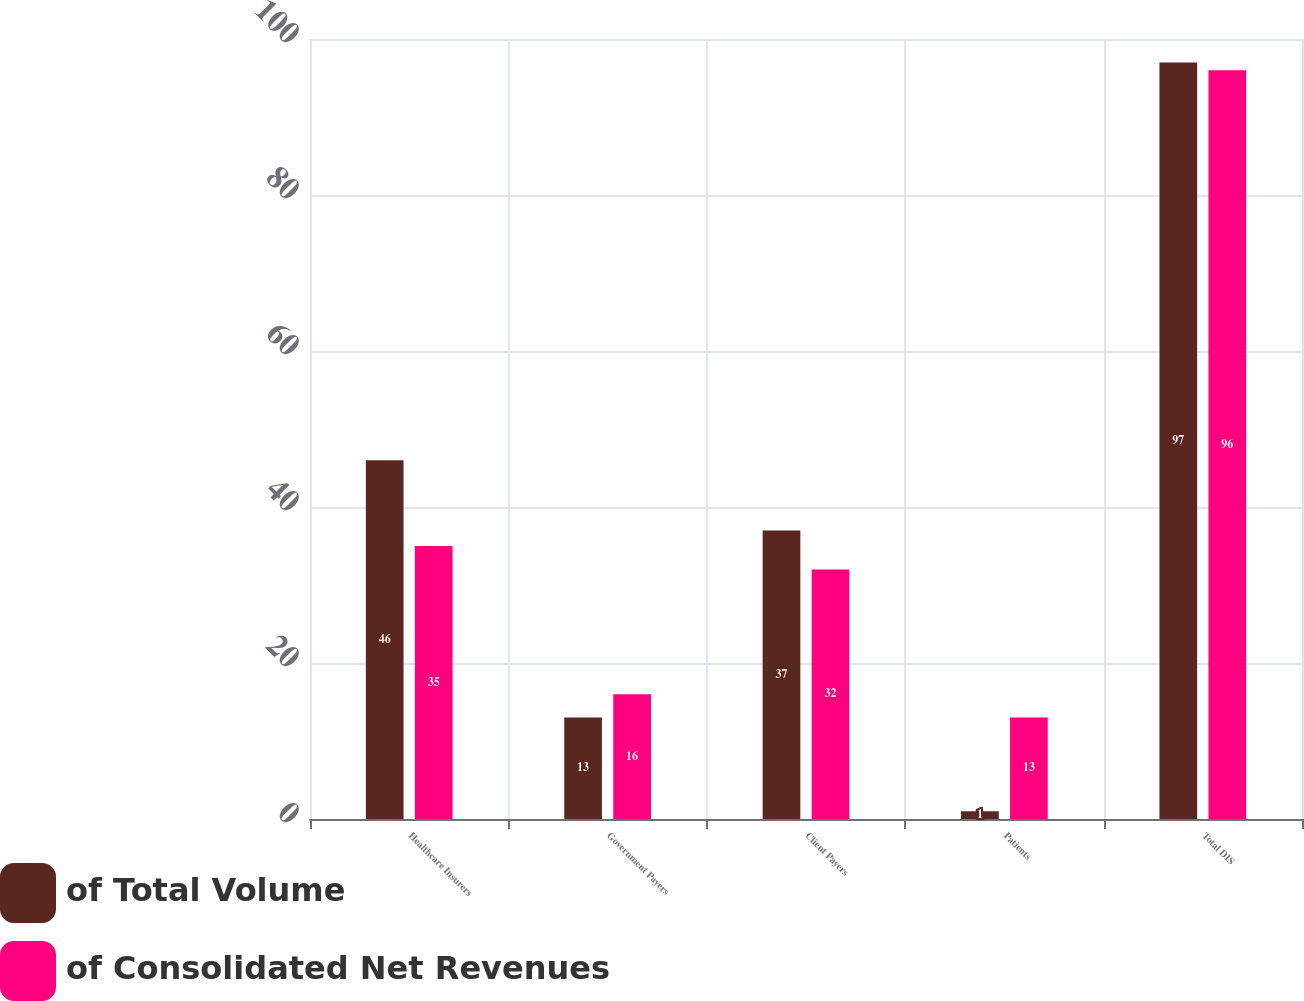Convert chart to OTSL. <chart><loc_0><loc_0><loc_500><loc_500><stacked_bar_chart><ecel><fcel>Healthcare Insurers<fcel>Government Payers<fcel>Client Payers<fcel>Patients<fcel>Total DIS<nl><fcel>of Total Volume<fcel>46<fcel>13<fcel>37<fcel>1<fcel>97<nl><fcel>of Consolidated Net Revenues<fcel>35<fcel>16<fcel>32<fcel>13<fcel>96<nl></chart> 